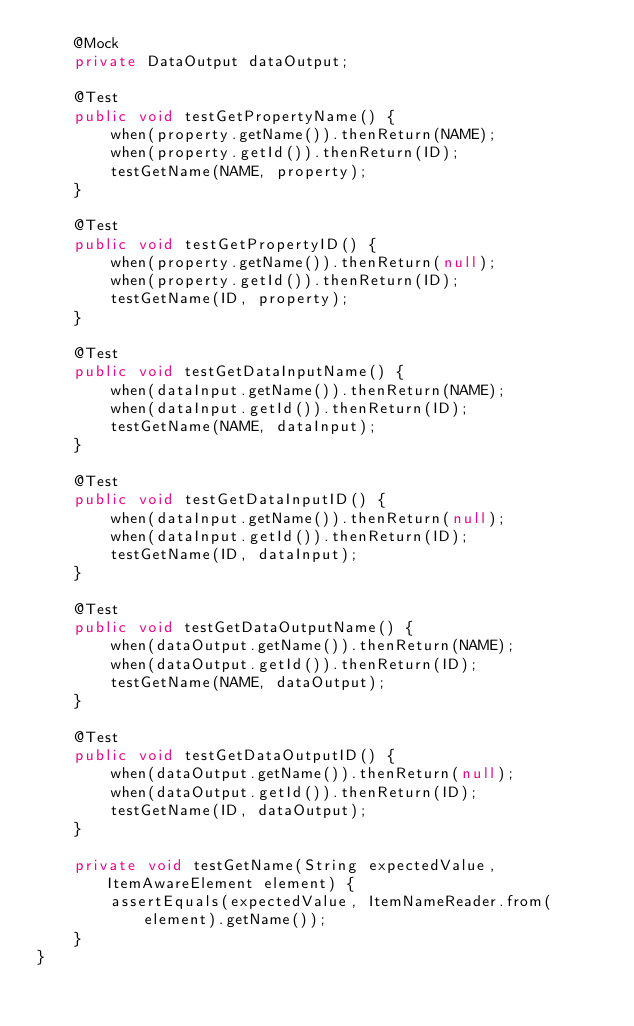<code> <loc_0><loc_0><loc_500><loc_500><_Java_>    @Mock
    private DataOutput dataOutput;

    @Test
    public void testGetPropertyName() {
        when(property.getName()).thenReturn(NAME);
        when(property.getId()).thenReturn(ID);
        testGetName(NAME, property);
    }

    @Test
    public void testGetPropertyID() {
        when(property.getName()).thenReturn(null);
        when(property.getId()).thenReturn(ID);
        testGetName(ID, property);
    }

    @Test
    public void testGetDataInputName() {
        when(dataInput.getName()).thenReturn(NAME);
        when(dataInput.getId()).thenReturn(ID);
        testGetName(NAME, dataInput);
    }

    @Test
    public void testGetDataInputID() {
        when(dataInput.getName()).thenReturn(null);
        when(dataInput.getId()).thenReturn(ID);
        testGetName(ID, dataInput);
    }

    @Test
    public void testGetDataOutputName() {
        when(dataOutput.getName()).thenReturn(NAME);
        when(dataOutput.getId()).thenReturn(ID);
        testGetName(NAME, dataOutput);
    }

    @Test
    public void testGetDataOutputID() {
        when(dataOutput.getName()).thenReturn(null);
        when(dataOutput.getId()).thenReturn(ID);
        testGetName(ID, dataOutput);
    }

    private void testGetName(String expectedValue, ItemAwareElement element) {
        assertEquals(expectedValue, ItemNameReader.from(element).getName());
    }
}
</code> 